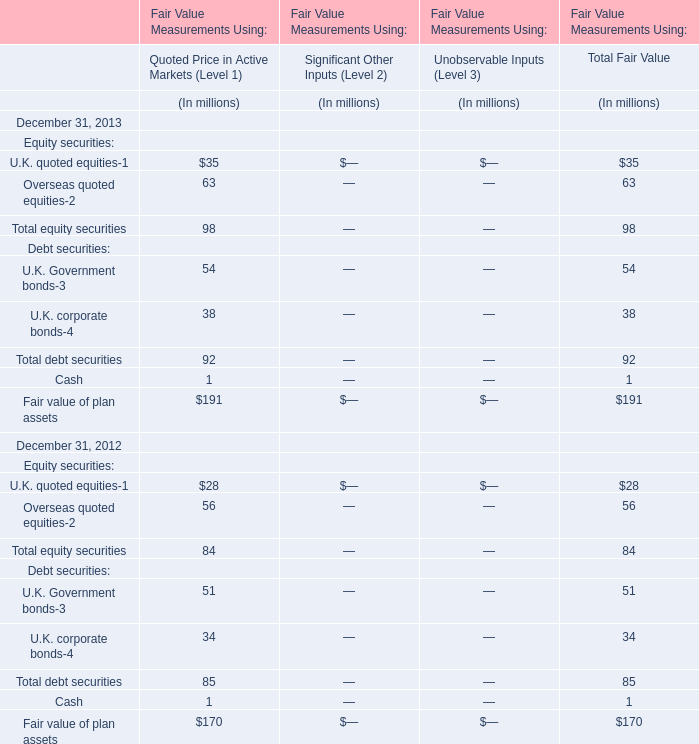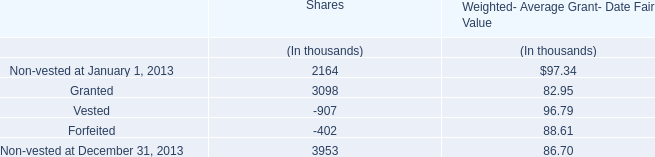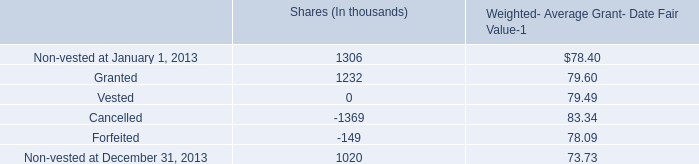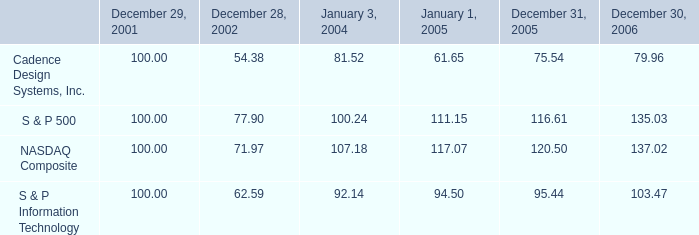what is the rate of return of an investment in cadence design systems inc from 2001 to 2004? 
Computations: ((81.52 - 100) / 100)
Answer: -0.1848. 